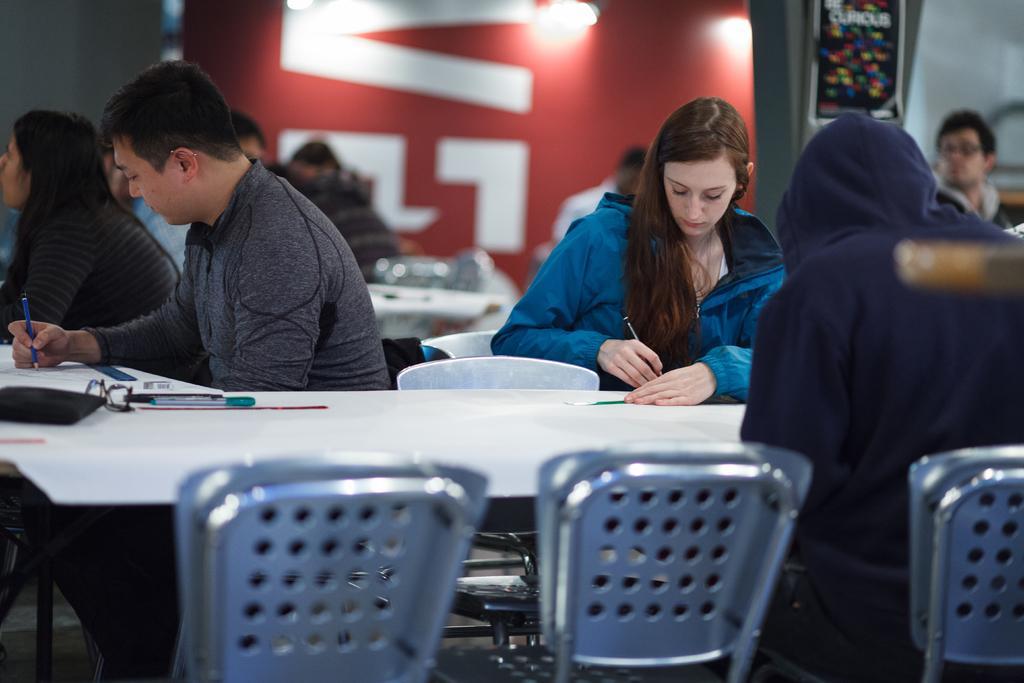Please provide a concise description of this image. In this image, on the right there is a woman. On the left there is a man and a woman. In the middle there is a table on that there are pens, wallet and papers. At the bottom there are chairs, a person. In the background there are tables, chairs, people, posters, lights and a wall. 